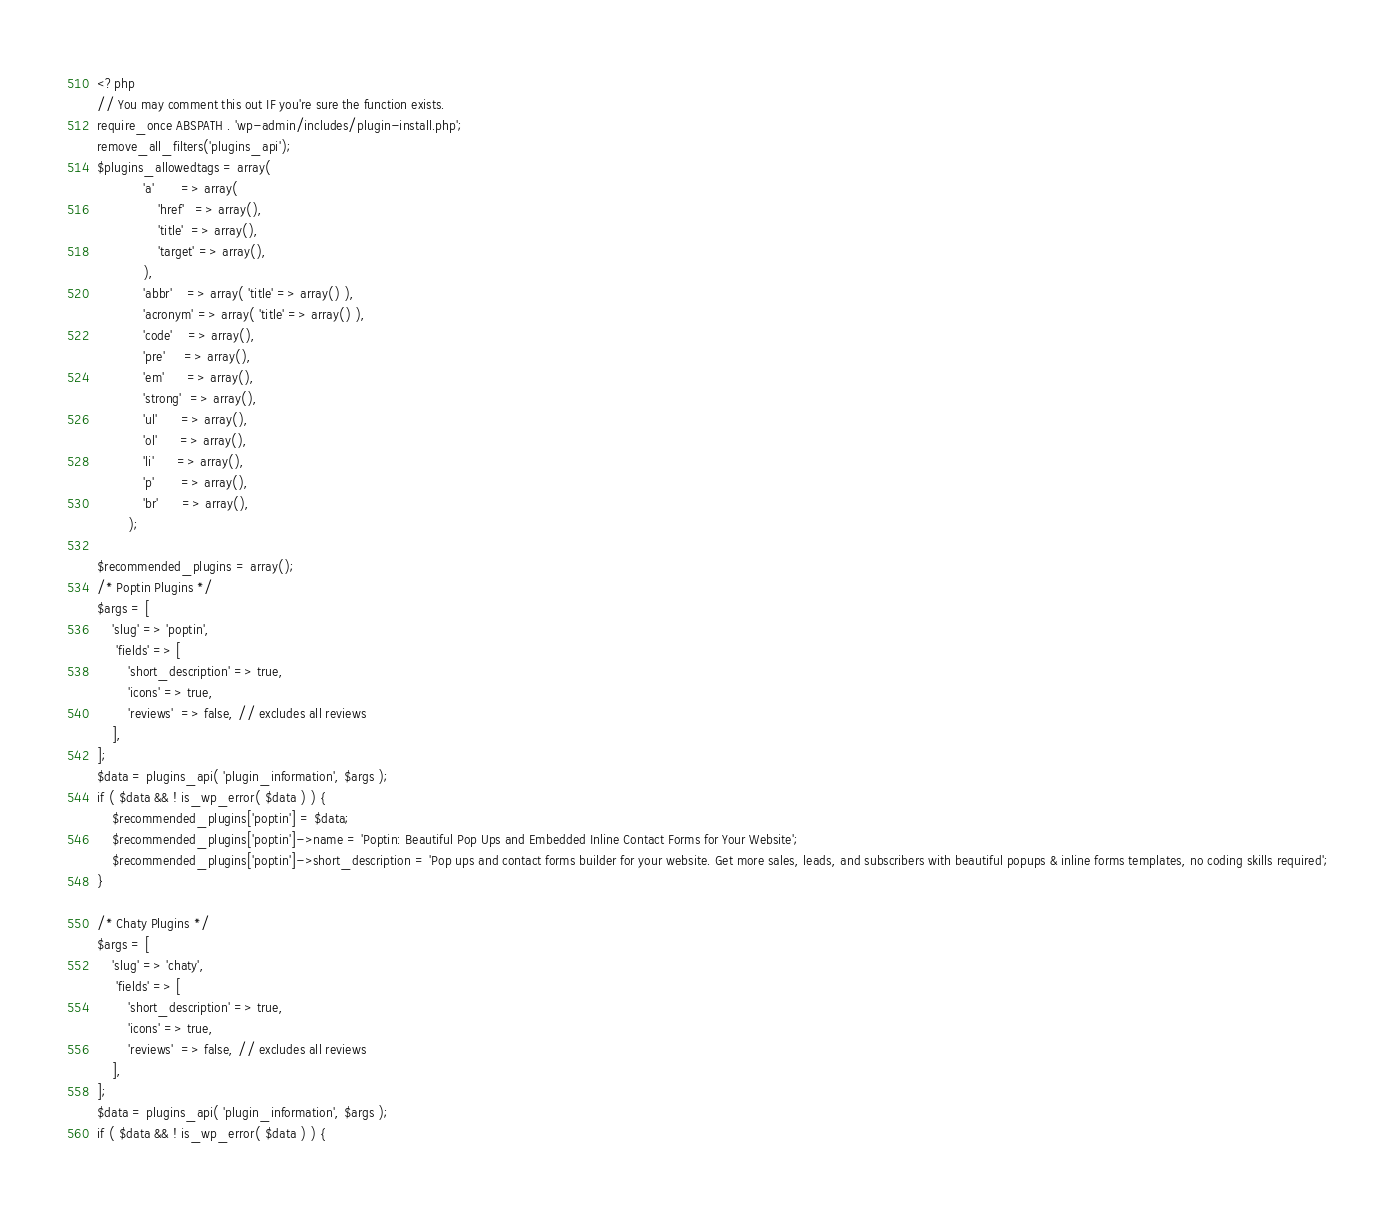<code> <loc_0><loc_0><loc_500><loc_500><_PHP_><?php
// You may comment this out IF you're sure the function exists.
require_once ABSPATH . 'wp-admin/includes/plugin-install.php';
remove_all_filters('plugins_api');
$plugins_allowedtags = array(
			'a'       => array(
				'href'   => array(),
				'title'  => array(),
				'target' => array(),
			),
			'abbr'    => array( 'title' => array() ),
			'acronym' => array( 'title' => array() ),
			'code'    => array(),
			'pre'     => array(),
			'em'      => array(),
			'strong'  => array(),
			'ul'      => array(),
			'ol'      => array(),
			'li'      => array(),
			'p'       => array(),
			'br'      => array(),
		);

$recommended_plugins = array();
/* Poptin Plugins */
$args = [
    'slug' => 'poptin',
	 'fields' => [
        'short_description' => true,        
        'icons' => true, 
        'reviews'  => false, // excludes all reviews        
    ],
];
$data = plugins_api( 'plugin_information', $args );
if ( $data && ! is_wp_error( $data ) ) {
	$recommended_plugins['poptin'] = $data;
	$recommended_plugins['poptin']->name = 'Poptin: Beautiful Pop Ups and Embedded Inline Contact Forms for Your Website';
	$recommended_plugins['poptin']->short_description = 'Pop ups and contact forms builder for your website. Get more sales, leads, and subscribers with beautiful popups & inline forms templates, no coding skills required';
}

/* Chaty Plugins */
$args = [
    'slug' => 'chaty',
	 'fields' => [
        'short_description' => true,
        'icons' => true, 
        'reviews'  => false, // excludes all reviews
    ],
];
$data = plugins_api( 'plugin_information', $args );
if ( $data && ! is_wp_error( $data ) ) {</code> 